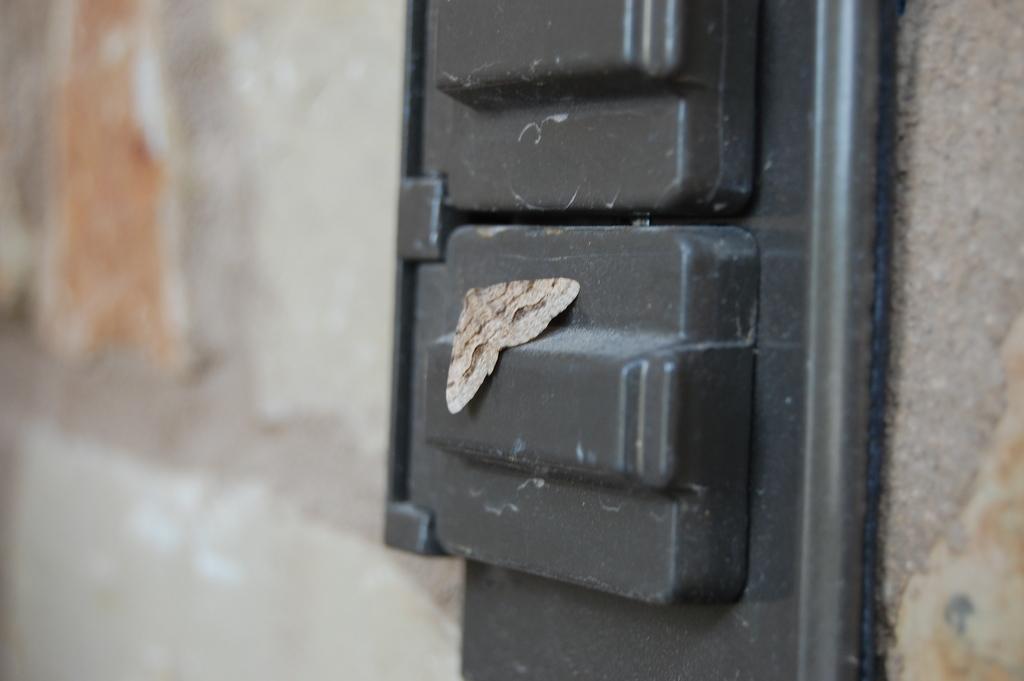Can you describe this image briefly? In the picture I can see fly laying on the black color thing. 